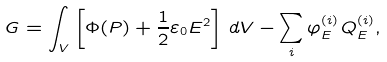<formula> <loc_0><loc_0><loc_500><loc_500>G = \int _ { V } \left [ \Phi ( P ) + \frac { 1 } { 2 } \varepsilon _ { 0 } E ^ { 2 } \right ] \, d V - \sum _ { i } \varphi _ { E } ^ { ( i ) } \, Q _ { E } ^ { ( i ) } ,</formula> 